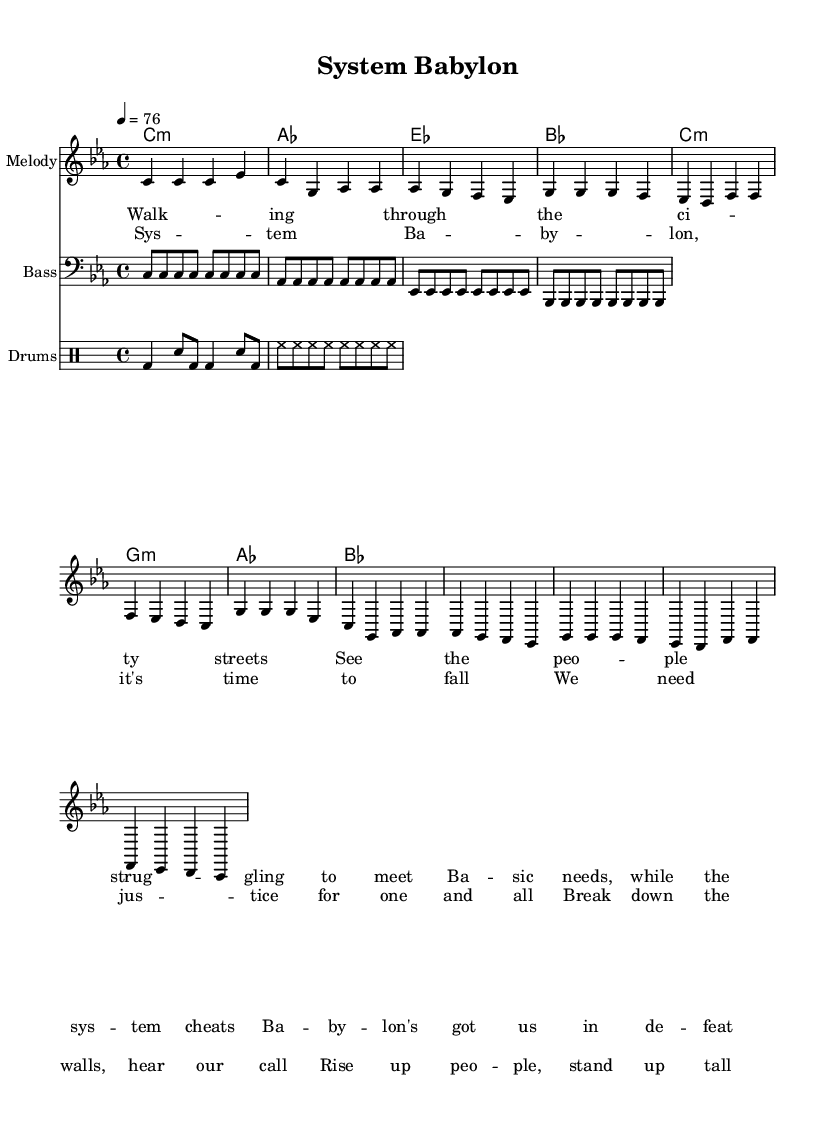What is the time signature of this music? The time signature indicated in the score is 4/4, meaning there are four beats in each measure and the quarter note receives one beat.
Answer: 4/4 What key is this piece written in? The key signature shown at the beginning is C minor, which contains three flats: B-flat, E-flat, and A-flat.
Answer: C minor What is the tempo marking for the piece? The tempo is indicated as quarter note equals 76, meaning the song should be played at a pace where the quarter note is counted at a speed of 76 beats per minute.
Answer: 76 How many measures are in the melody part? The melody is broken down into eight distinct measures, each separated by bar lines in the sheet music.
Answer: 8 What message does the chorus promote? The chorus encourages unity and justice, stating the need to break down barriers and rise up as a community, reflecting the theme of social justice inherent in reggae music.
Answer: Justice for one and all How is the bass line structured in relation to the key? The bass line uses notes that align with the C minor scale and complements the harmonic structure presented by the chord listings, creating a cohesive sound that reinforces the song’s message.
Answer: C minor What type of instrument is indicated for the melody? The melody part is notated specifically for a single melodic instrument, typically a lead instrument that carries the melody. This is usual for reggae songs, which often highlight vocal or instrumental leads.
Answer: Melody 